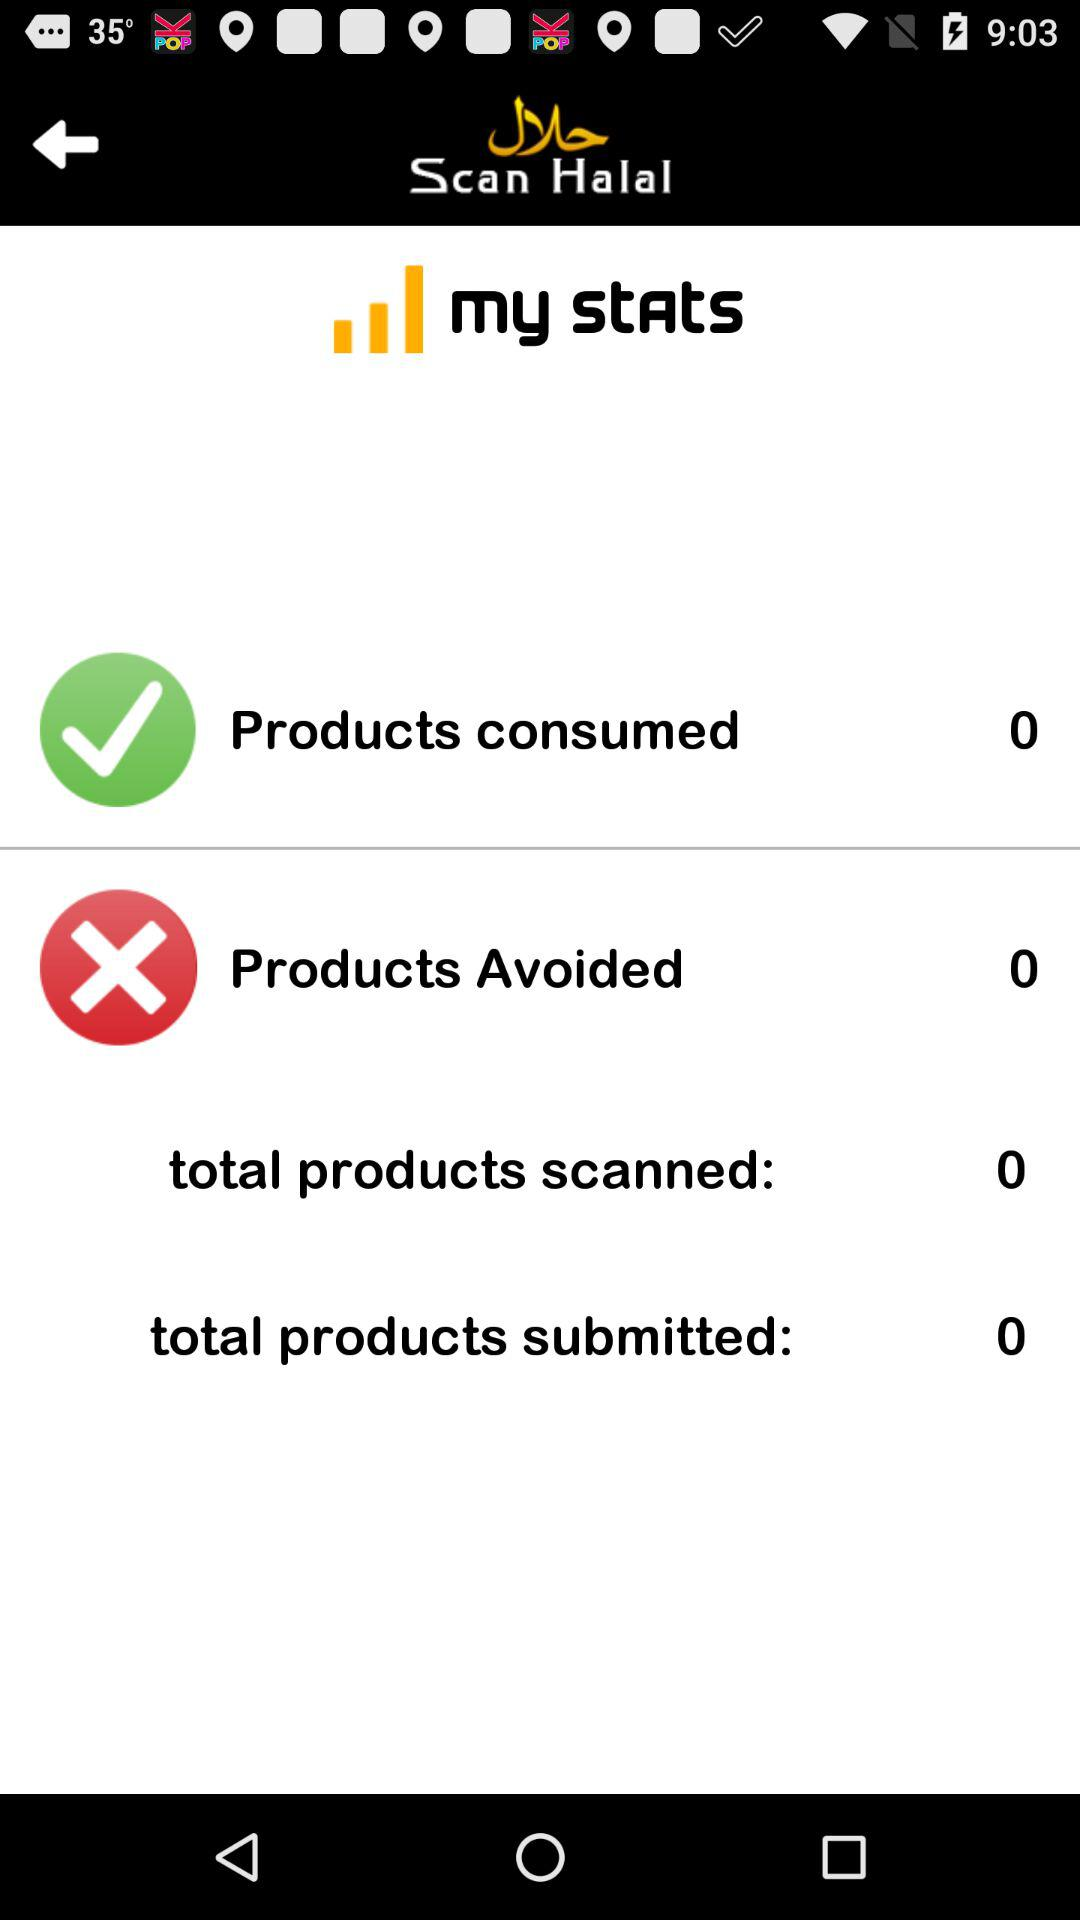What is the selected checkbox?
When the provided information is insufficient, respond with <no answer>. <no answer> 